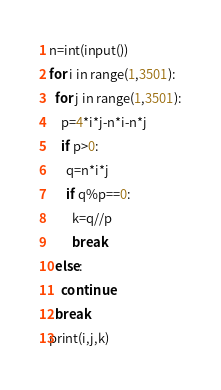<code> <loc_0><loc_0><loc_500><loc_500><_Python_>n=int(input())
for i in range(1,3501):
  for j in range(1,3501):
    p=4*i*j-n*i-n*j
    if p>0:
      q=n*i*j
      if q%p==0:
        k=q//p
        break
  else:
    continue
  break
print(i,j,k)</code> 